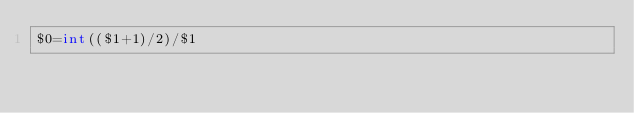<code> <loc_0><loc_0><loc_500><loc_500><_Awk_>$0=int(($1+1)/2)/$1</code> 